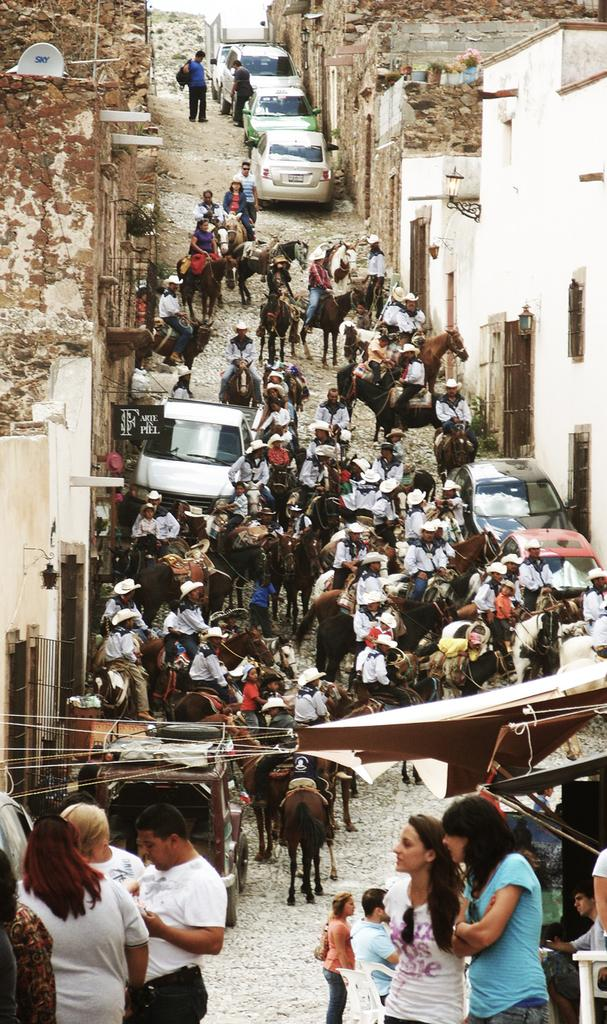What is happening in the image involving the group of people? The people are riding horses in the image. Where are the horses and people located? The horses and people are in a lane. What else can be seen in the image? There are cars parked on the side in the image. What type of vegetable is being used as a swing by the people in the image? There is no vegetable being used as a swing in the image; the people are riding horses. How does the stomach of the horses affect their ability to ride in the image? The stomachs of the horses do not affect their ability to ride in the image, as the focus is on the people riding them. 